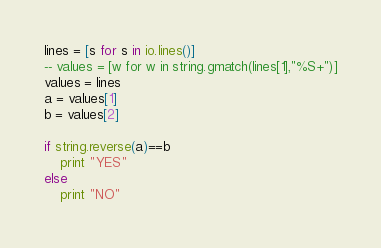<code> <loc_0><loc_0><loc_500><loc_500><_MoonScript_>lines = [s for s in io.lines()]
-- values = [w for w in string.gmatch(lines[1],"%S+")]
values = lines
a = values[1]
b = values[2]

if string.reverse(a)==b
	print "YES"
else
	print "NO"</code> 